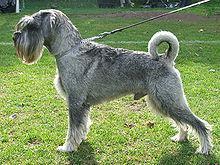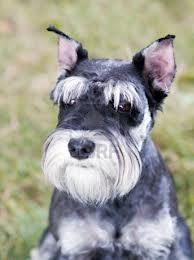The first image is the image on the left, the second image is the image on the right. Evaluate the accuracy of this statement regarding the images: "At least one of the dogs is sitting on the cement.". Is it true? Answer yes or no. No. 